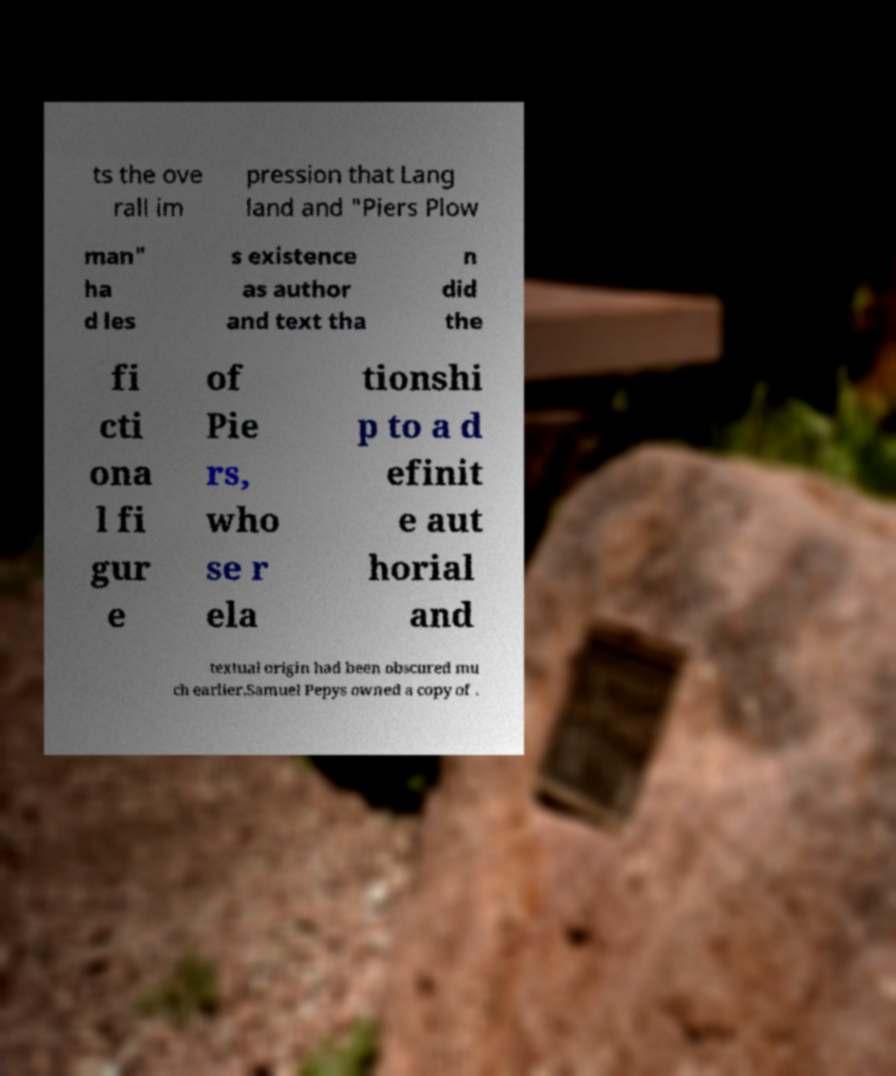Could you assist in decoding the text presented in this image and type it out clearly? ts the ove rall im pression that Lang land and "Piers Plow man" ha d les s existence as author and text tha n did the fi cti ona l fi gur e of Pie rs, who se r ela tionshi p to a d efinit e aut horial and textual origin had been obscured mu ch earlier.Samuel Pepys owned a copy of . 